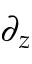Convert formula to latex. <formula><loc_0><loc_0><loc_500><loc_500>\partial _ { z }</formula> 